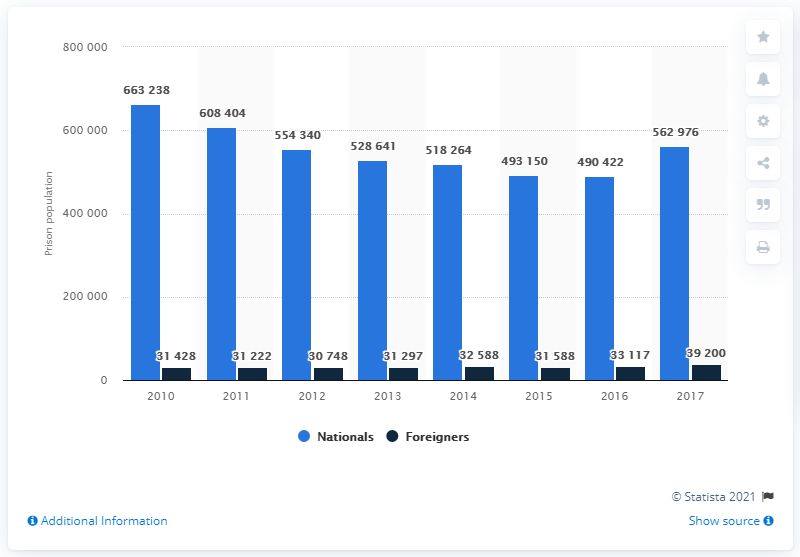Indicate a few pertinent items in this graphic. In 2017, there were approximately 39,200 foreign prisoners incarcerated in Russia. 